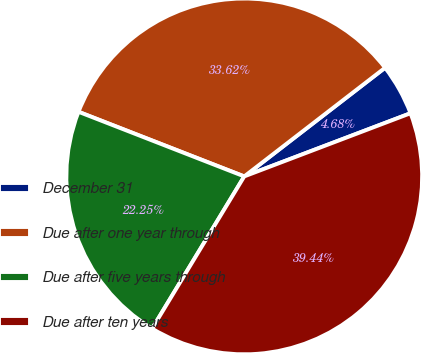Convert chart. <chart><loc_0><loc_0><loc_500><loc_500><pie_chart><fcel>December 31<fcel>Due after one year through<fcel>Due after five years through<fcel>Due after ten years<nl><fcel>4.68%<fcel>33.62%<fcel>22.25%<fcel>39.44%<nl></chart> 